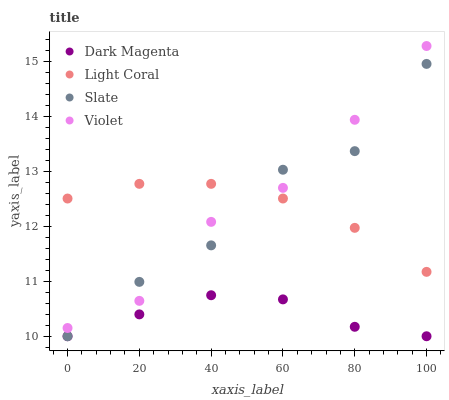Does Dark Magenta have the minimum area under the curve?
Answer yes or no. Yes. Does Violet have the maximum area under the curve?
Answer yes or no. Yes. Does Slate have the minimum area under the curve?
Answer yes or no. No. Does Slate have the maximum area under the curve?
Answer yes or no. No. Is Light Coral the smoothest?
Answer yes or no. Yes. Is Slate the roughest?
Answer yes or no. Yes. Is Dark Magenta the smoothest?
Answer yes or no. No. Is Dark Magenta the roughest?
Answer yes or no. No. Does Slate have the lowest value?
Answer yes or no. Yes. Does Violet have the lowest value?
Answer yes or no. No. Does Violet have the highest value?
Answer yes or no. Yes. Does Slate have the highest value?
Answer yes or no. No. Is Dark Magenta less than Light Coral?
Answer yes or no. Yes. Is Violet greater than Dark Magenta?
Answer yes or no. Yes. Does Dark Magenta intersect Slate?
Answer yes or no. Yes. Is Dark Magenta less than Slate?
Answer yes or no. No. Is Dark Magenta greater than Slate?
Answer yes or no. No. Does Dark Magenta intersect Light Coral?
Answer yes or no. No. 